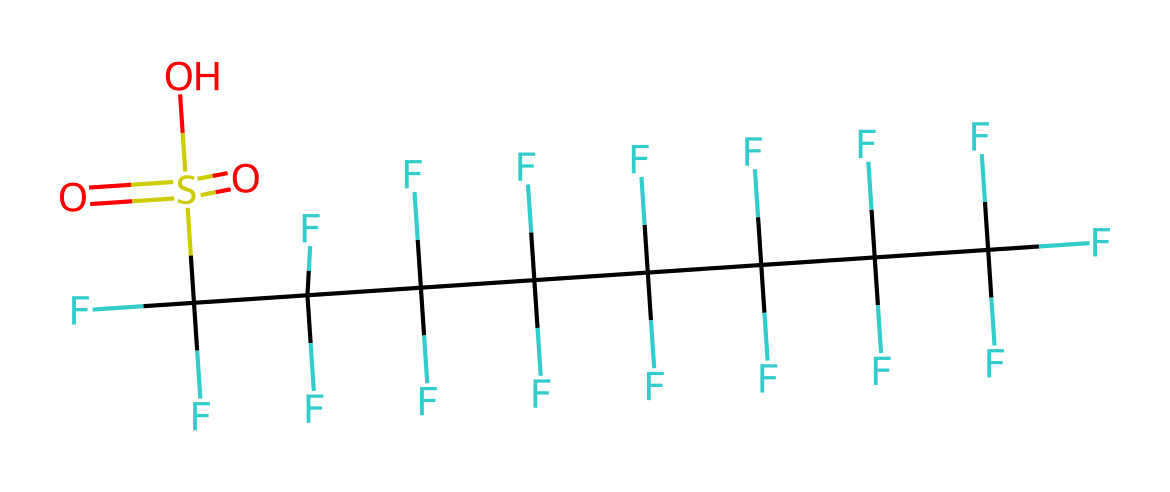What is the full name of this chemical? The SMILES representation indicates a fluorosurfactant with sulfonic acid functionality. Based on its structure, it is specifically identified as perfluorooctanesulfonic acid.
Answer: perfluorooctanesulfonic acid How many carbon atoms are present in the structure? By analyzing the SMILES, the long chain comprises eight carbon atoms (C), as indicated by the repeated patterns in the structure before the sulfonic acid group.
Answer: eight What type of functional group is present in this chemical? The presence of the "S(=O)(=O)O" part indicates that this compound has a sulfonic acid functional group, characterized by a sulfur atom bonded to oxygen atoms and a hydroxyl group.
Answer: sulfonic acid How many fluorine atoms are attached to the carbon skeleton? In the SMILES, each carbon in the chain is attached to three fluorine atoms, and since there are eight carbons, that results in a total of 24 fluorine atoms (3 fluorines per carbon × 8 carbons).
Answer: twenty-four What property does the fluorinated structure impart to this surfactant? The extensive fluorination of this compound results in lower surface tension and increased hydrophobic properties, making it effective as a surfactant.
Answer: lower surface tension How does the presence of the sulfonic acid group influence the properties of this compound? The sulfonic acid group increases the water solubility of this chemical and enhances its surfactant properties due to its ability to interact with water, thus aiding in emulsification.
Answer: increases water solubility 